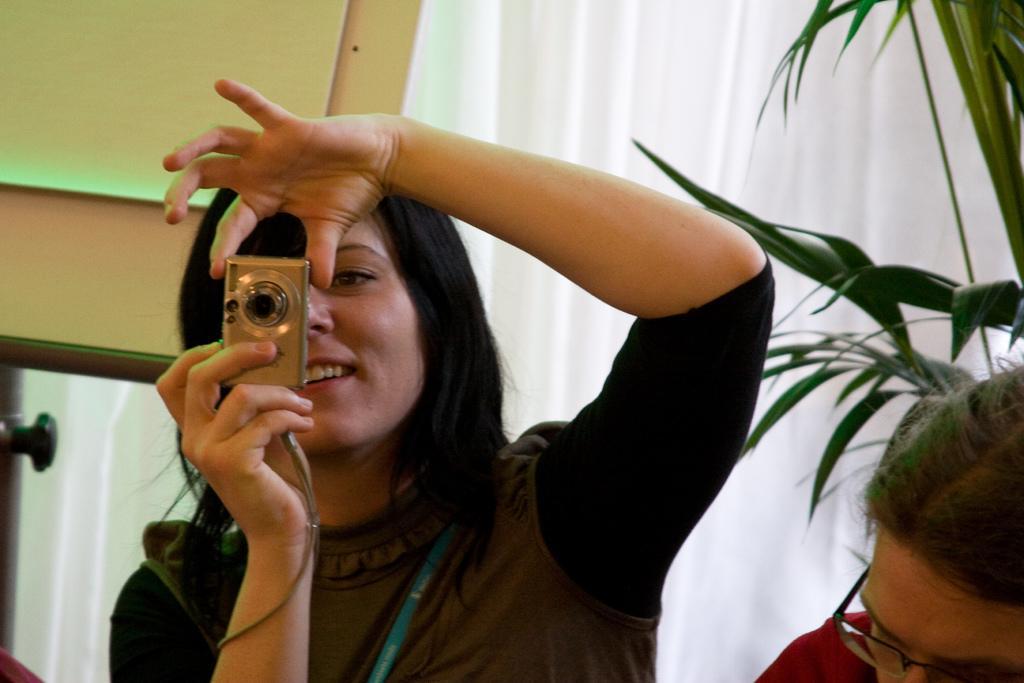Describe this image in one or two sentences. In this image, In the left side there is a woman she is standing and she is holding a camera she is taking a picture, In the right side there is a person siting and there is a green color plant, In the background there is a white color curtain. 